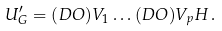<formula> <loc_0><loc_0><loc_500><loc_500>U _ { G } ^ { \prime } = ( D O ) V _ { 1 } \dots ( D O ) V _ { p } H \, .</formula> 